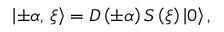<formula> <loc_0><loc_0><loc_500><loc_500>\left | \pm \alpha , \, \xi \right \rangle = D \left ( \pm \alpha \right ) S \left ( \xi \right ) \left | 0 \right \rangle ,</formula> 